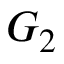Convert formula to latex. <formula><loc_0><loc_0><loc_500><loc_500>G _ { 2 }</formula> 